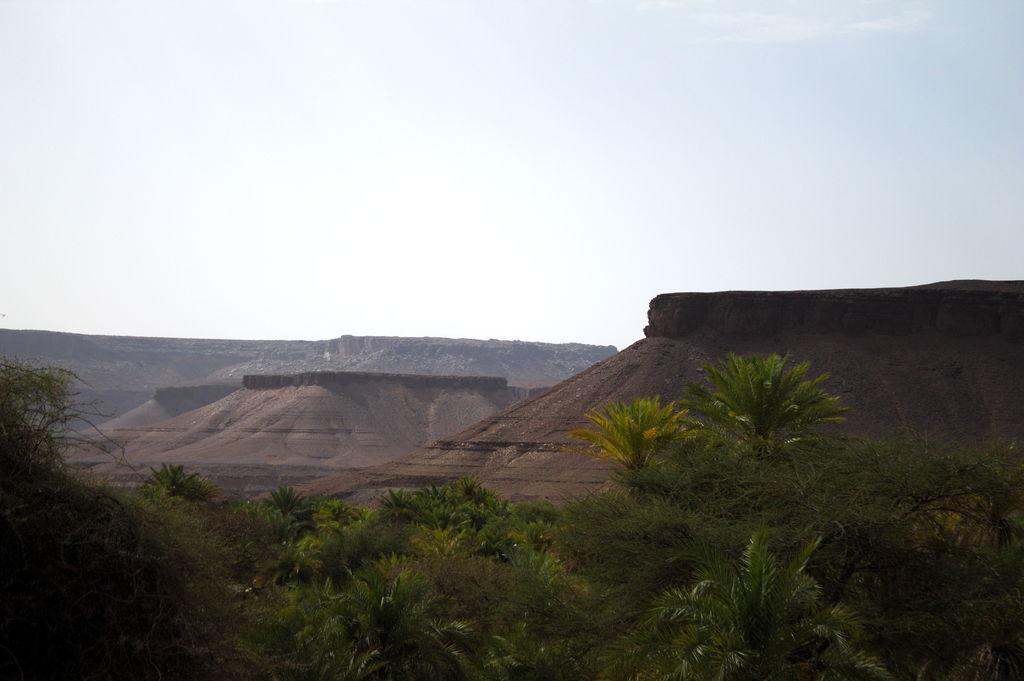What can be seen in the background of the image? The sky is visible in the image. What type of natural features are present in the image? There are hills in the image. What type of vegetation is present in the image? Trees are present in the image. What type of garden can be seen in the image? There is no garden present in the image; it features the sky, hills, and trees. 